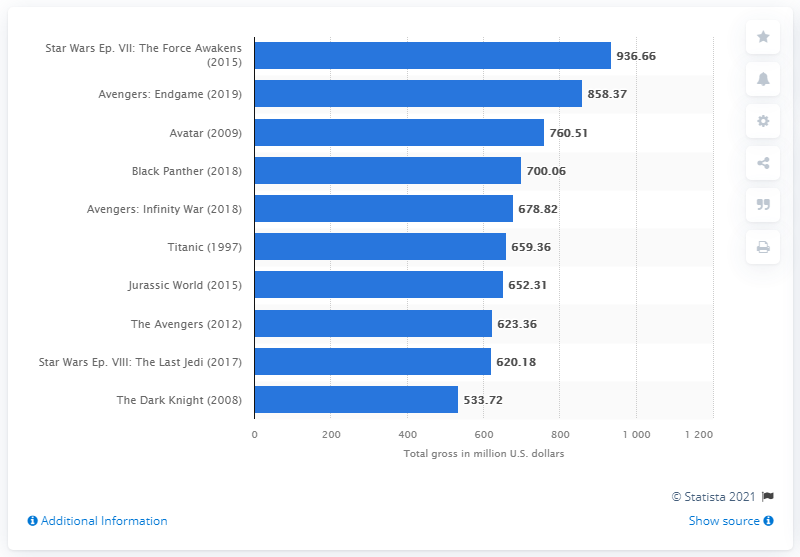Draw attention to some important aspects in this diagram. The total gross of "Star Wars Ep. VII: The Force Awakens" was 936.66 million dollars. According to box office sales data in 2009, 'Avatar' grossed a total of 760.51 million U.S. dollars in the United States. 